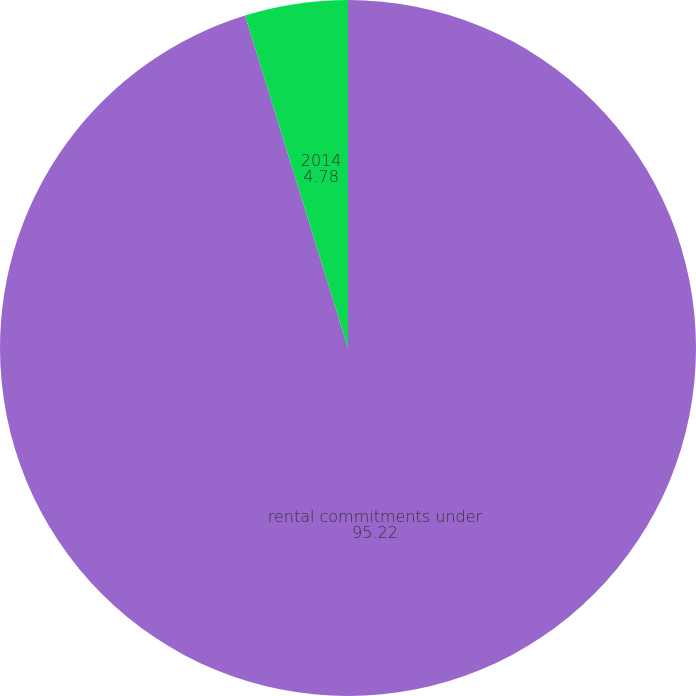Convert chart. <chart><loc_0><loc_0><loc_500><loc_500><pie_chart><fcel>rental commitments under<fcel>2014<nl><fcel>95.22%<fcel>4.78%<nl></chart> 